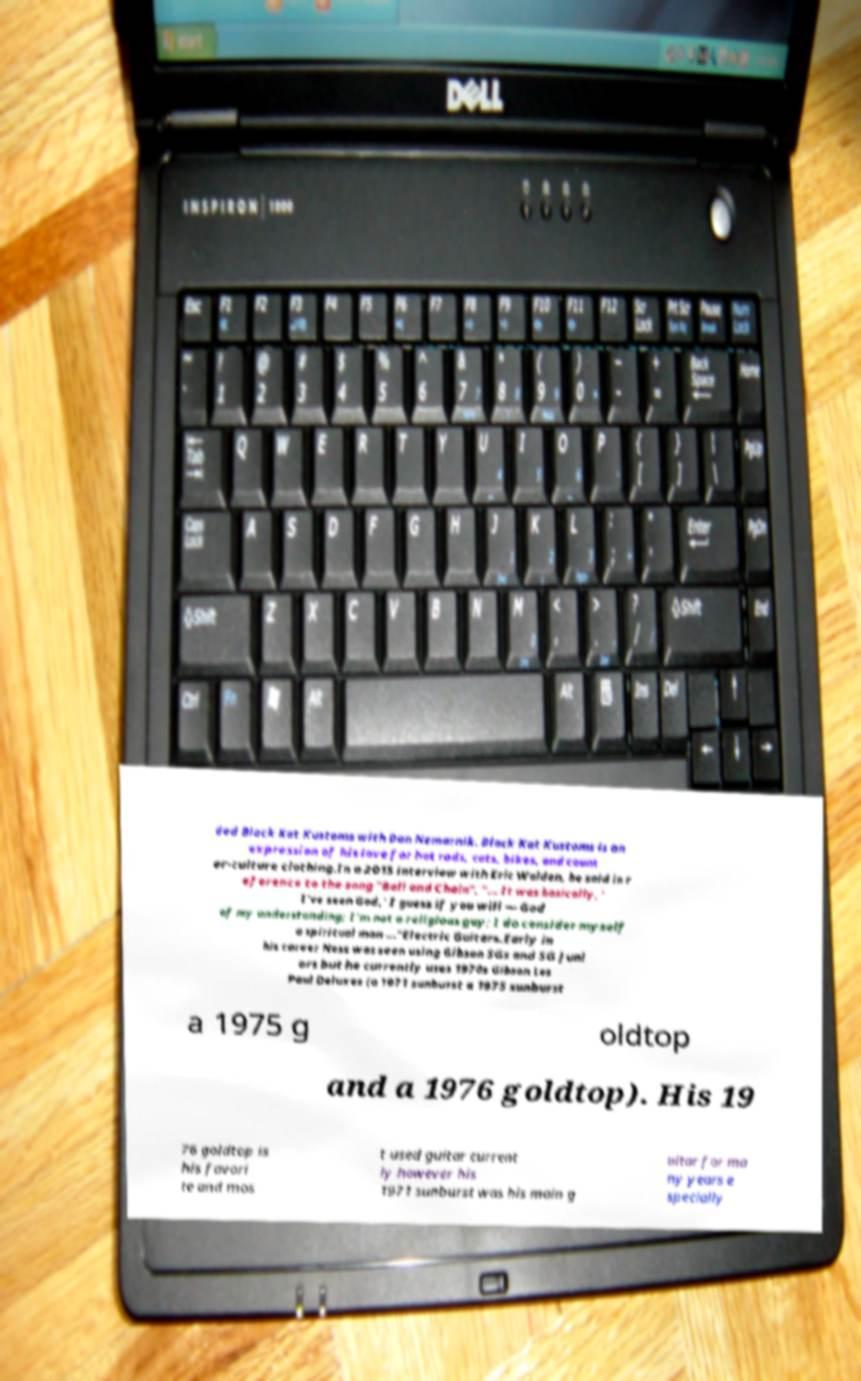For documentation purposes, I need the text within this image transcribed. Could you provide that? ded Black Kat Kustoms with Don Nemarnik. Black Kat Kustoms is an expression of his love for hot rods, cats, bikes, and count er-culture clothing.In a 2015 interview with Eric Walden, he said in r eference to the song "Ball and Chain", "... It was basically, ' I've seen God,' I guess if you will — God of my understanding; I'm not a religious guy; I do consider myself a spiritual man ..."Electric Guitars.Early in his career Ness was seen using Gibson SGs and SG Juni ors but he currently uses 1970s Gibson Les Paul Deluxes (a 1971 sunburst a 1975 sunburst a 1975 g oldtop and a 1976 goldtop). His 19 76 goldtop is his favori te and mos t used guitar current ly however his 1971 sunburst was his main g uitar for ma ny years e specially 